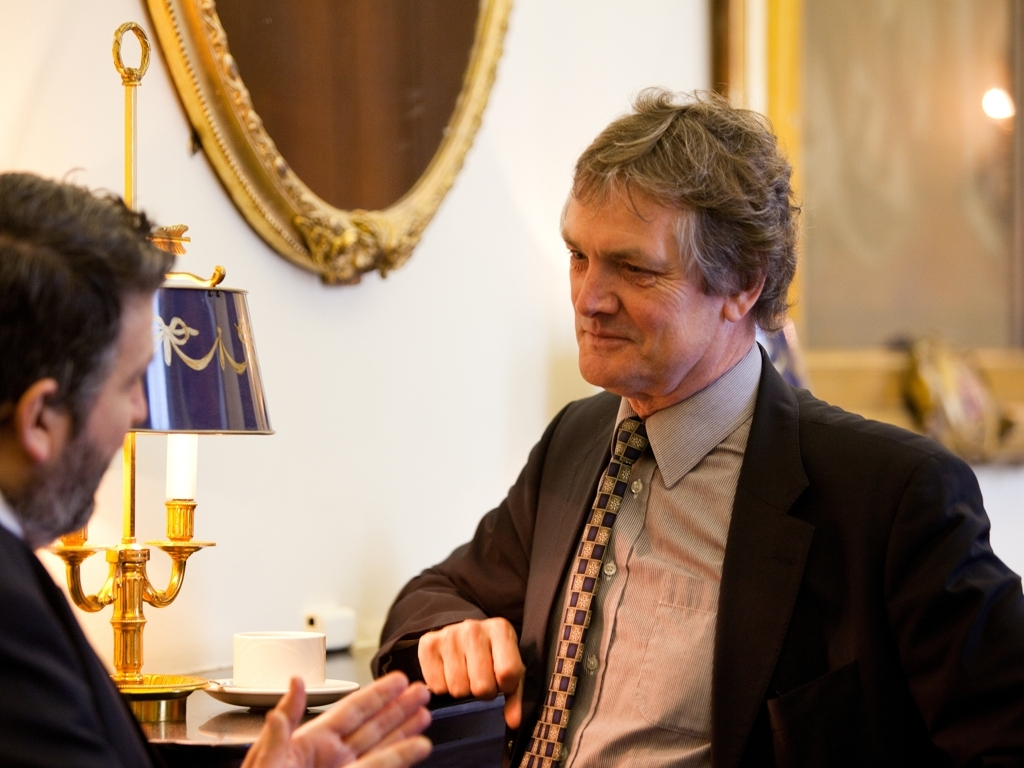How are the colors in the image?
A. Monochromatic
B. Faded
C. Vivid
Answer with the option's letter from the given choices directly.
 C. 